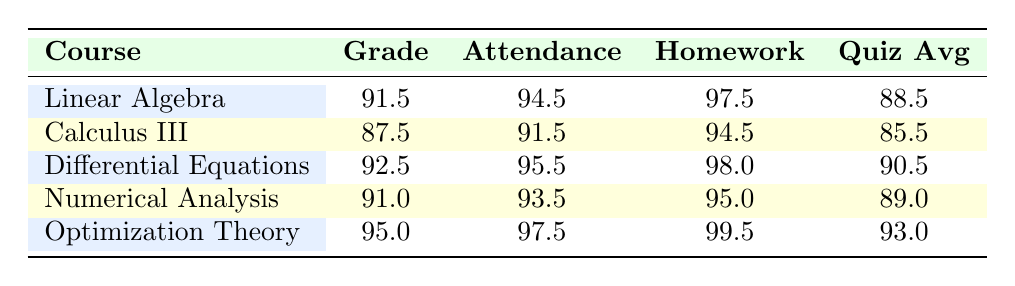What is the average grade for the Linear Algebra course? To find the average grade for Linear Algebra, I look at the table and see that there are two students with grades of 92 and 91. The sum of these grades is 92 + 91 = 183. There are 2 students, so the average is 183 / 2 = 91.5.
Answer: 91.5 Which course has the highest average attendance? By checking the attendance values in the table, I see that Optimization Theory has an average attendance of 97.5, which is higher than all other courses listed.
Answer: Optimization Theory Is the average quiz score for Differential Equations greater than 90? The average quiz score for Differential Equations is 90.5, which is indeed greater than 90.
Answer: Yes What is the difference in average homework completion between Calculus III and Numerical Analysis? The average homework completion for Calculus III is 94.5, and for Numerical Analysis, it is 95.0. The difference is calculated as 95.0 - 94.5 = 0.5.
Answer: 0.5 How many courses have an average grade above 90? I check the grade averages: Linear Algebra (91.5), Differential Equations (92.5), Numerical Analysis (91.0), and Optimization Theory (95.0) are all above 90. There are 4 courses meeting this criterion.
Answer: 4 What is the combined average attendance for all the courses listed in the table? To find the combined average attendance, I add the attendance values: 94.5 + 91.5 + 95.5 + 93.5 + 97.5 = 472.5. Next, I divide by the number of courses (5): 472.5 / 5 = 94.5.
Answer: 94.5 Are there any courses with a quiz average below 88? Checking the quiz averages, all courses have averages: 88.5, 85.5, 90.5, 89.0, and 93.0. The lowest average is 85.5 for Calculus III, which is below 88.
Answer: Yes What is the total of homework completion averages for Linear Algebra and Optimization Theory? The homework completion average for Linear Algebra is 97.5, and for Optimization Theory, it is 99.5. The total is 97.5 + 99.5 = 197.
Answer: 197 